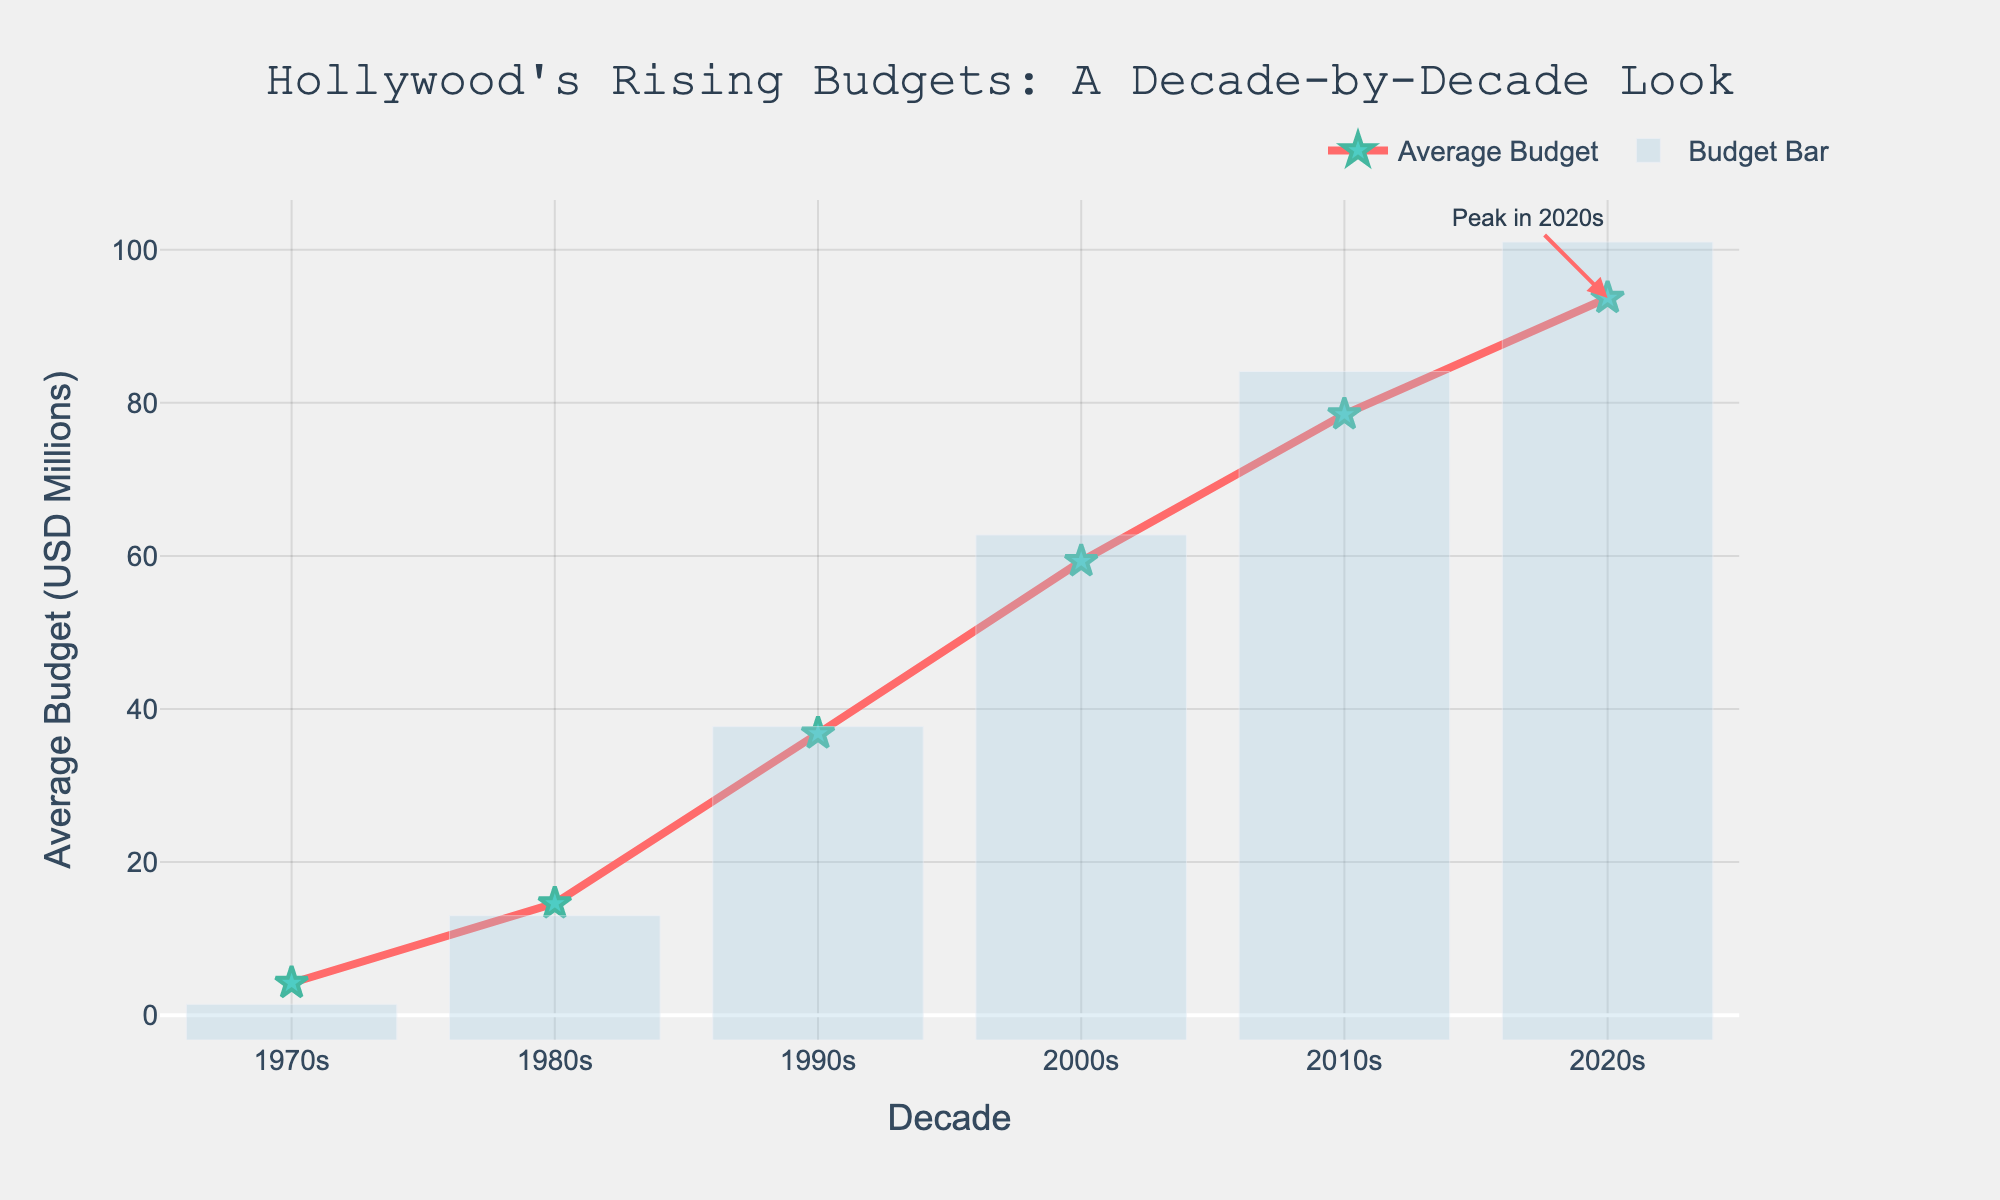What's the decade with the highest average film production budget? Look at the values on the y-axis and identify the highest point on the line graph. The peak is labeled in the 2020s.
Answer: 2020s How much did the average film production budget increase from the 1970s to the 2020s? Subtract the average budget in the 1970s (4.2 million) from the average budget in the 2020s (93.7 million).
Answer: 89.5 million In which decade did the average film production budget first exceed 50 million? Follow the line graph and find the point where the y-axis value exceeds 50 million for the first time, which occurs in the 2000s.
Answer: 2000s What is the average of the average film production budgets for the 1990s, 2000s, and 2010s? Add the budgets for the 1990s (36.8 million), 2000s (59.3 million), and 2010s (78.5 million), then divide by 3. (36.8 + 59.3 + 78.5) / 3 = 174.6 / 3 = 58.2 million
Answer: 58.2 million Which decade saw the largest percentage increase in average budget compared to the previous decade? Calculate the percentage increase for each decade: 
(1980s: (14.6-4.2)/4.2 * 100 = 247.6%),
(1990s: (36.8 - 14.6)/14.6 * 100 = 152.1%),
(2000s: (59.3 - 36.8)/36.8 * 100 = 61.1%),
(2010s: (78.5 - 59.3)/59.3 * 100 = 32.3%),
(2020s: (93.7 - 78.5)/78.5 * 100 = 19.3%)
The largest increase is from the 1970s to the 1980s.
Answer: 1980s Compare the average budgets in the 1980s and the 1990s. Which one is greater and by how much? The average budget in the 1980s is 14.6 million, and in the 1990s is 36.8 million. Subtract the 1980s value from the 1990s value. 36.8 - 14.6 = 22.2 million.
Answer: 1990s by 22.2 million 